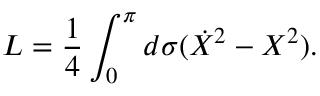Convert formula to latex. <formula><loc_0><loc_0><loc_500><loc_500>L = \frac { 1 } { 4 } \int _ { 0 } ^ { \pi } d \sigma ( \dot { X } ^ { 2 } - X ^ { 2 } ) .</formula> 